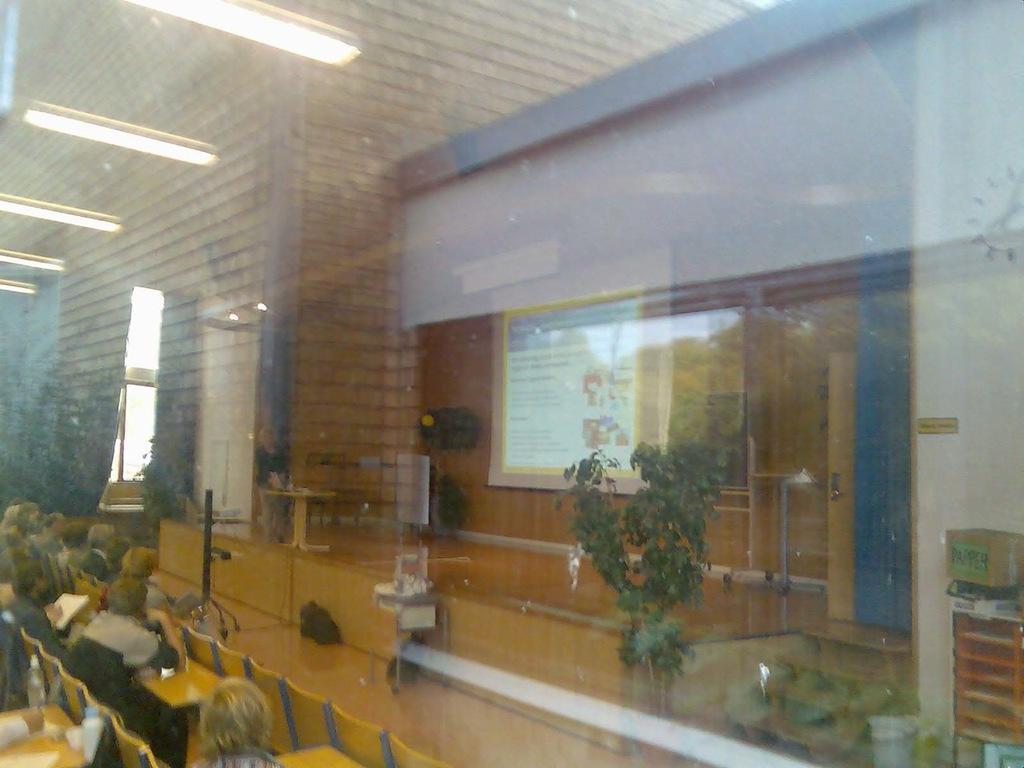Please provide a concise description of this image. This image is clicked in a conference. At the bottom, there are many persons sitting in the chairs. The chairs are in yellow color. At the top, there is a roof along with lights. In the front, we can see a wall and a projector screen. In the middle, there is a potted plants. And we can see a door. 